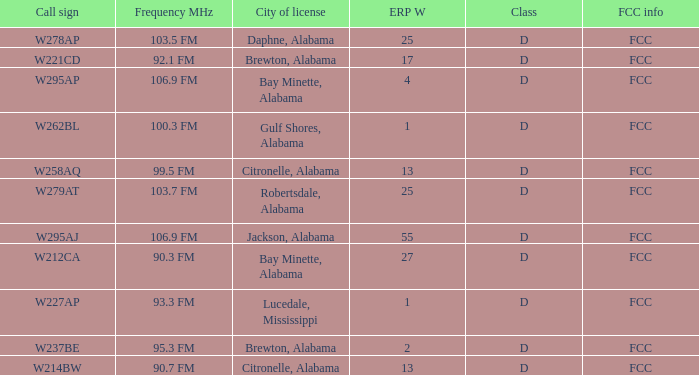State the call sign associated with erp w of 27 W212CA. 